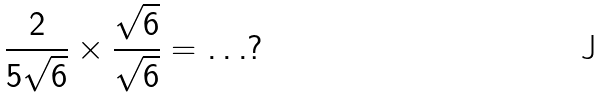Convert formula to latex. <formula><loc_0><loc_0><loc_500><loc_500>\frac { 2 } { 5 \sqrt { 6 } } \times \frac { \sqrt { 6 } } { \sqrt { 6 } } = \dots ?</formula> 